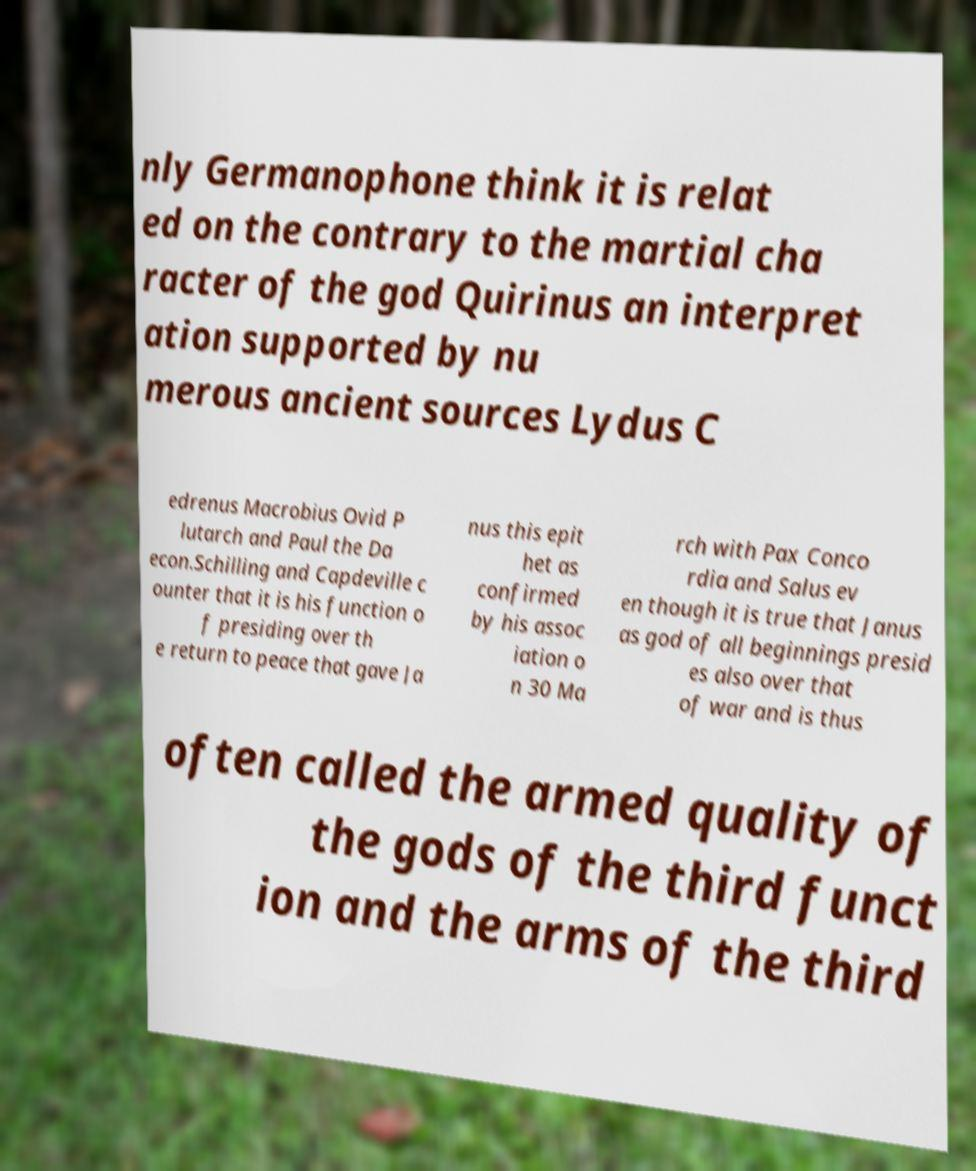Can you read and provide the text displayed in the image?This photo seems to have some interesting text. Can you extract and type it out for me? nly Germanophone think it is relat ed on the contrary to the martial cha racter of the god Quirinus an interpret ation supported by nu merous ancient sources Lydus C edrenus Macrobius Ovid P lutarch and Paul the Da econ.Schilling and Capdeville c ounter that it is his function o f presiding over th e return to peace that gave Ja nus this epit het as confirmed by his assoc iation o n 30 Ma rch with Pax Conco rdia and Salus ev en though it is true that Janus as god of all beginnings presid es also over that of war and is thus often called the armed quality of the gods of the third funct ion and the arms of the third 